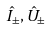<formula> <loc_0><loc_0><loc_500><loc_500>\hat { I } _ { \pm } , \hat { U } _ { \pm }</formula> 